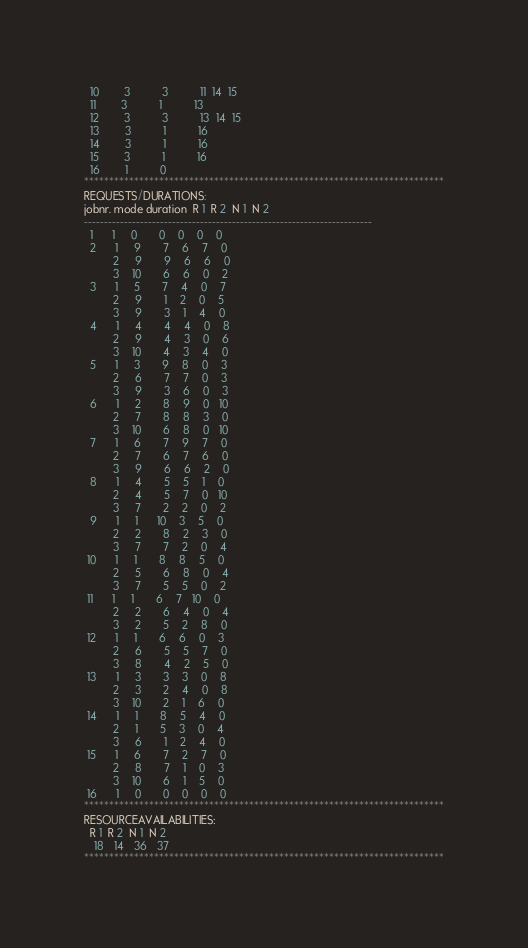<code> <loc_0><loc_0><loc_500><loc_500><_ObjectiveC_>  10        3          3          11  14  15
  11        3          1          13
  12        3          3          13  14  15
  13        3          1          16
  14        3          1          16
  15        3          1          16
  16        1          0        
************************************************************************
REQUESTS/DURATIONS:
jobnr. mode duration  R 1  R 2  N 1  N 2
------------------------------------------------------------------------
  1      1     0       0    0    0    0
  2      1     9       7    6    7    0
         2     9       9    6    6    0
         3    10       6    6    0    2
  3      1     5       7    4    0    7
         2     9       1    2    0    5
         3     9       3    1    4    0
  4      1     4       4    4    0    8
         2     9       4    3    0    6
         3    10       4    3    4    0
  5      1     3       9    8    0    3
         2     6       7    7    0    3
         3     9       3    6    0    3
  6      1     2       8    9    0   10
         2     7       8    8    3    0
         3    10       6    8    0   10
  7      1     6       7    9    7    0
         2     7       6    7    6    0
         3     9       6    6    2    0
  8      1     4       5    5    1    0
         2     4       5    7    0   10
         3     7       2    2    0    2
  9      1     1      10    3    5    0
         2     2       8    2    3    0
         3     7       7    2    0    4
 10      1     1       8    8    5    0
         2     5       6    8    0    4
         3     7       5    5    0    2
 11      1     1       6    7   10    0
         2     2       6    4    0    4
         3     2       5    2    8    0
 12      1     1       6    6    0    3
         2     6       5    5    7    0
         3     8       4    2    5    0
 13      1     3       3    3    0    8
         2     3       2    4    0    8
         3    10       2    1    6    0
 14      1     1       8    5    4    0
         2     1       5    3    0    4
         3     6       1    2    4    0
 15      1     6       7    2    7    0
         2     8       7    1    0    3
         3    10       6    1    5    0
 16      1     0       0    0    0    0
************************************************************************
RESOURCEAVAILABILITIES:
  R 1  R 2  N 1  N 2
   18   14   36   37
************************************************************************
</code> 